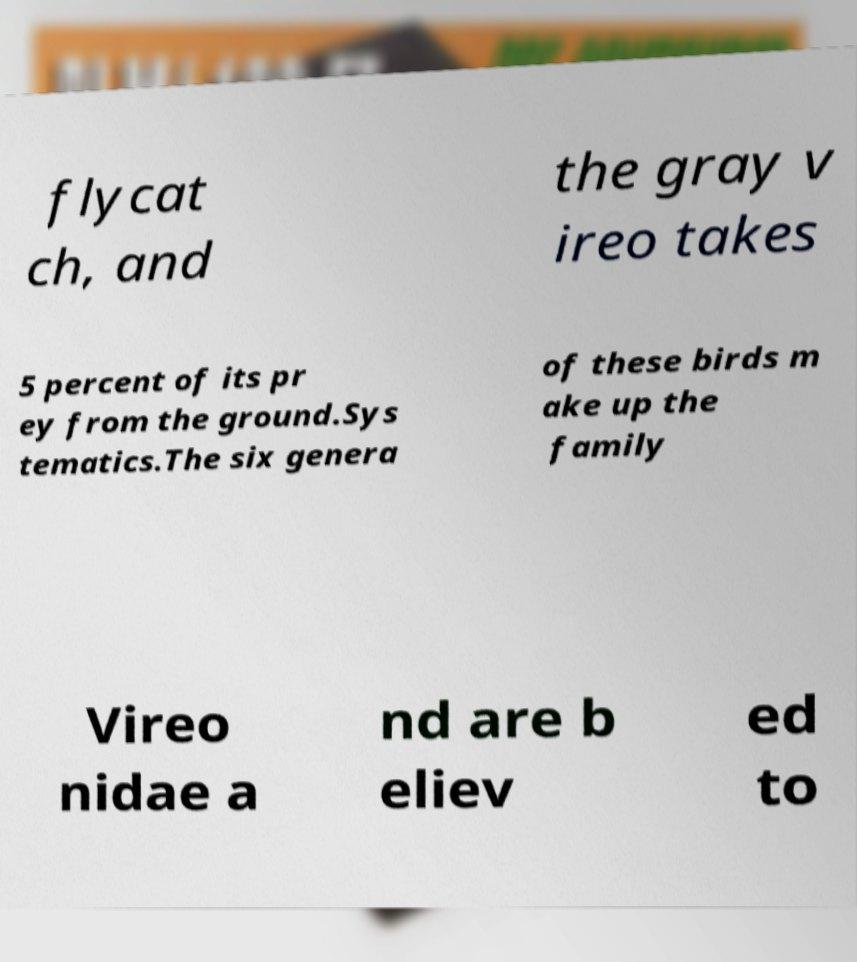There's text embedded in this image that I need extracted. Can you transcribe it verbatim? flycat ch, and the gray v ireo takes 5 percent of its pr ey from the ground.Sys tematics.The six genera of these birds m ake up the family Vireo nidae a nd are b eliev ed to 